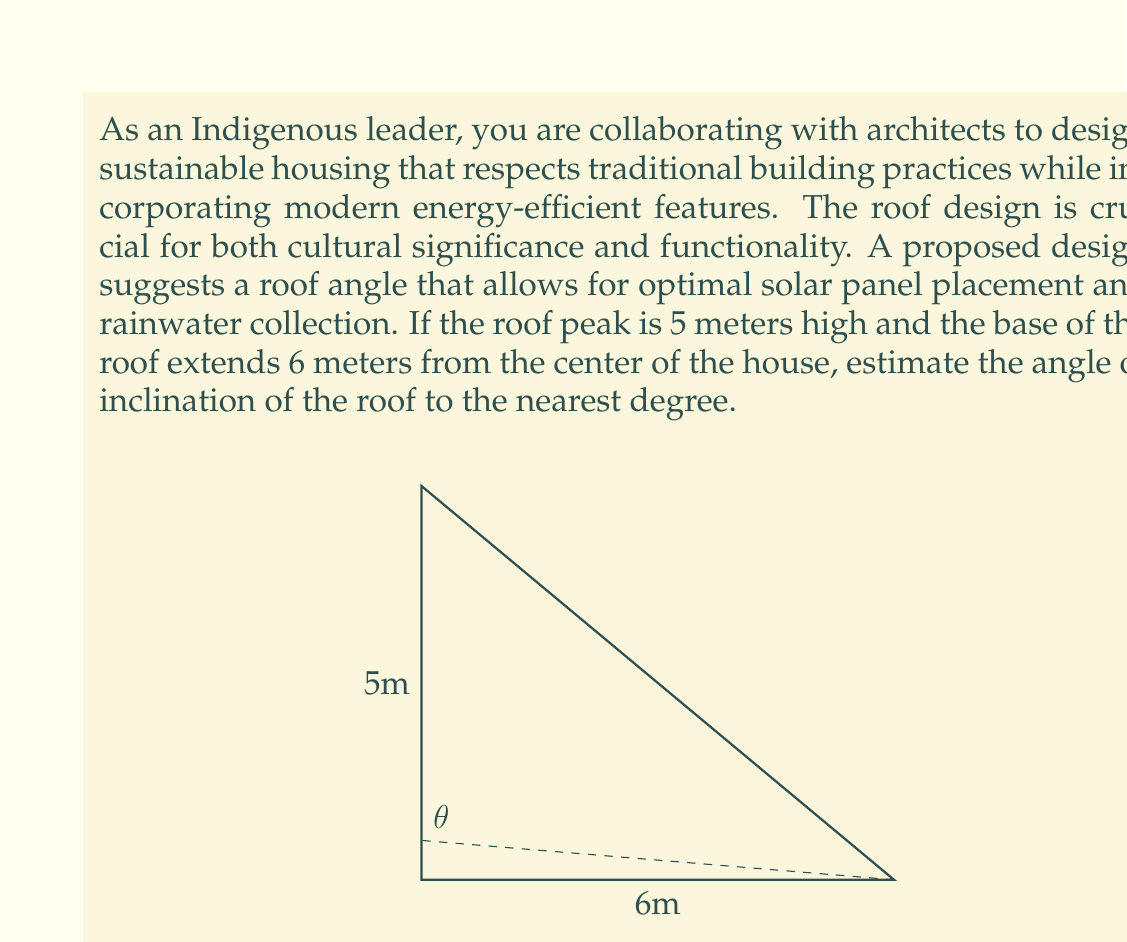Provide a solution to this math problem. To solve this problem, we'll use trigonometry, specifically the tangent function. Let's break it down step-by-step:

1) In this scenario, we have a right triangle where:
   - The adjacent side (half of the roof's base) is 6 meters
   - The opposite side (height of the roof peak) is 5 meters

2) The tangent of an angle in a right triangle is defined as the ratio of the opposite side to the adjacent side:

   $$\tan(\theta) = \frac{\text{opposite}}{\text{adjacent}}$$

3) Substituting our values:

   $$\tan(\theta) = \frac{5}{6}$$

4) To find the angle $\theta$, we need to use the inverse tangent (arctan or $\tan^{-1}$) function:

   $$\theta = \tan^{-1}(\frac{5}{6})$$

5) Using a calculator or computer:

   $$\theta \approx 39.8055^\circ$$

6) Rounding to the nearest degree:

   $$\theta \approx 40^\circ$$

This angle of inclination provides a good balance between traditional steep-roofed designs often found in Indigenous architecture and the optimal angle for solar panel efficiency in many latitudes. It also allows for effective rainwater runoff and collection, which aligns with sustainable water management practices.
Answer: The estimated angle of inclination for the roof is approximately $40^\circ$. 